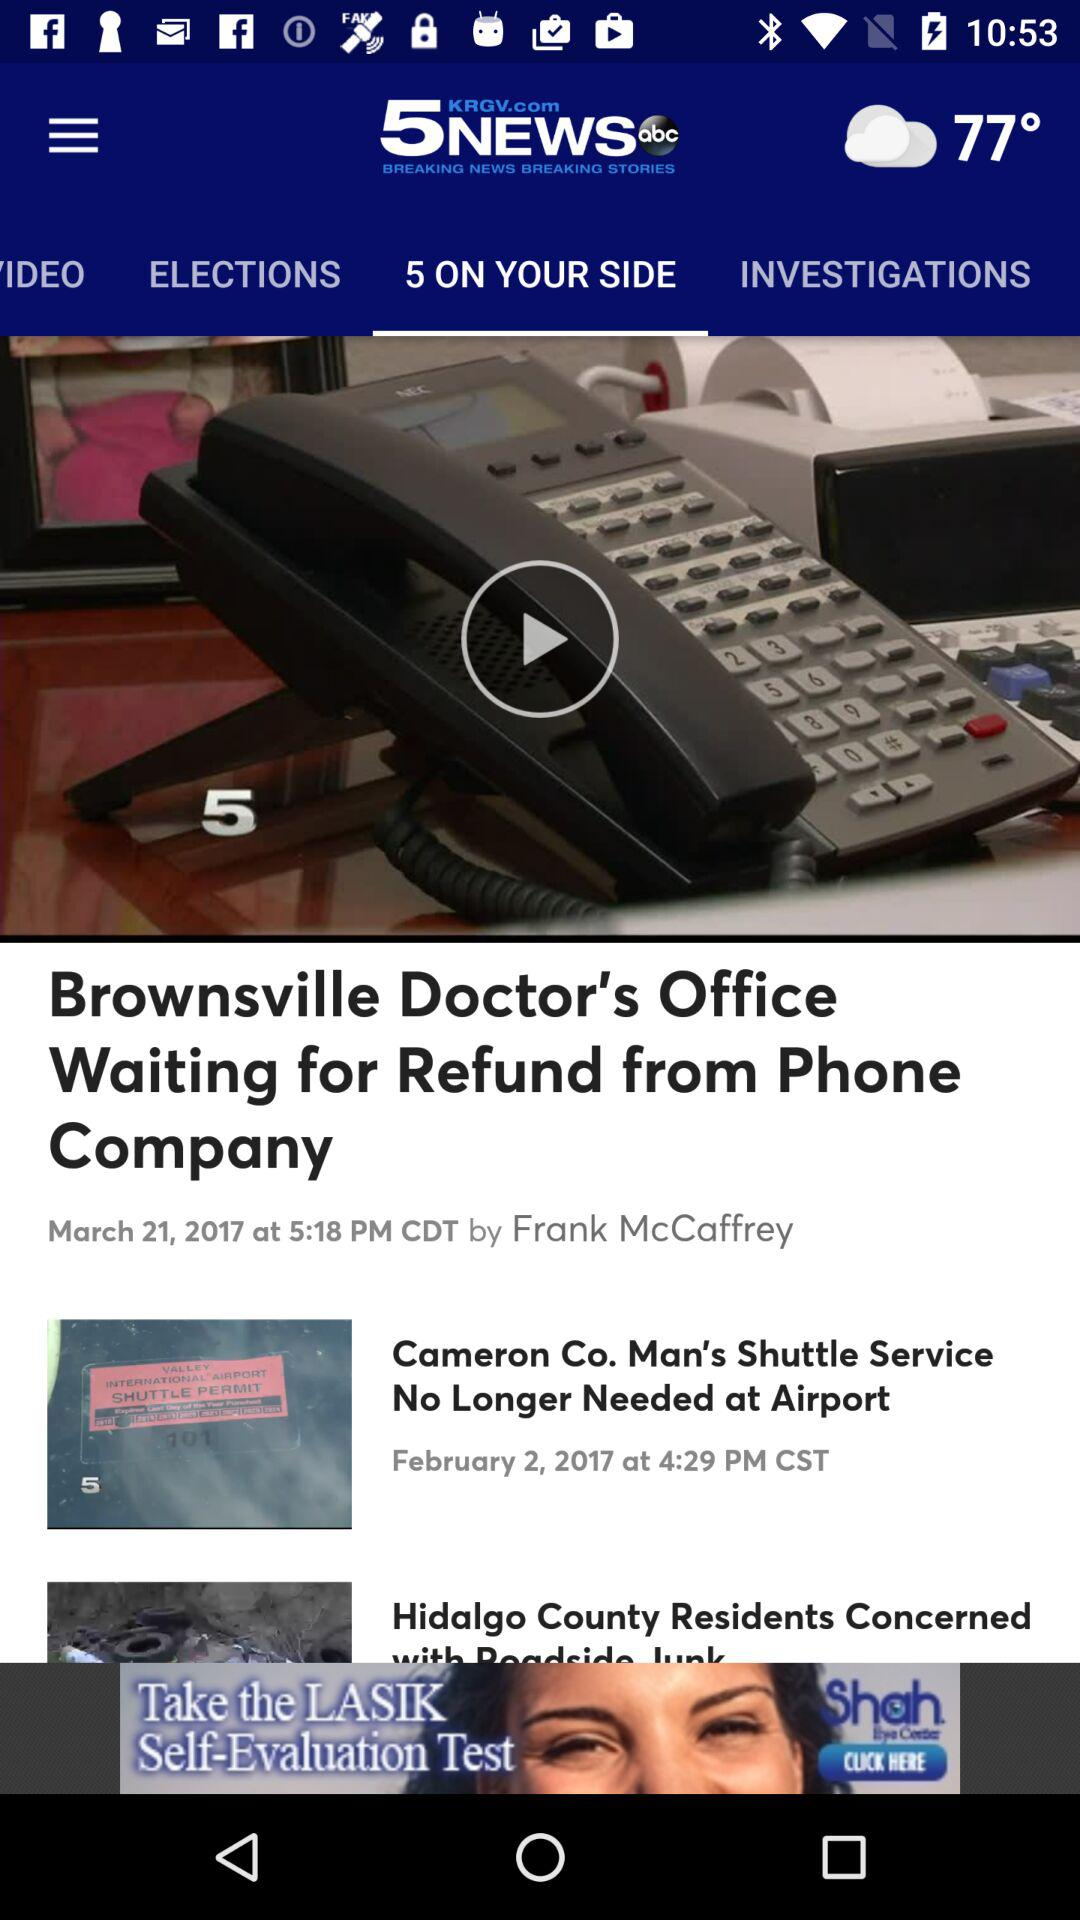Who uploaded the news "Brownsville Doctor's Office Waiting for Refund from Phone Company"? The news "Brownsville Doctor's Office Waiting for Refund from Phone Company" is received by Frank McCaffrey. 